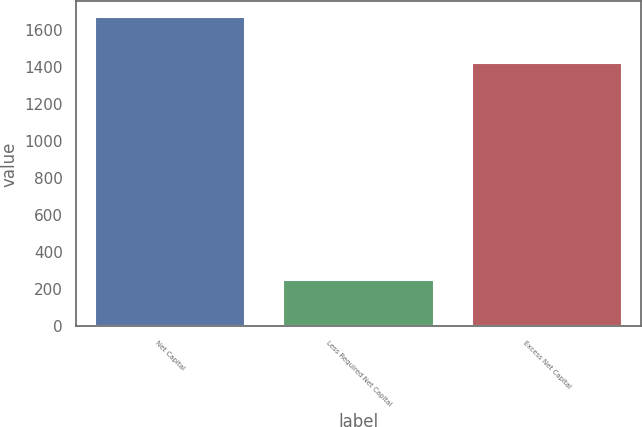Convert chart to OTSL. <chart><loc_0><loc_0><loc_500><loc_500><bar_chart><fcel>Net Capital<fcel>Less Required Net Capital<fcel>Excess Net Capital<nl><fcel>1669<fcel>250<fcel>1419<nl></chart> 